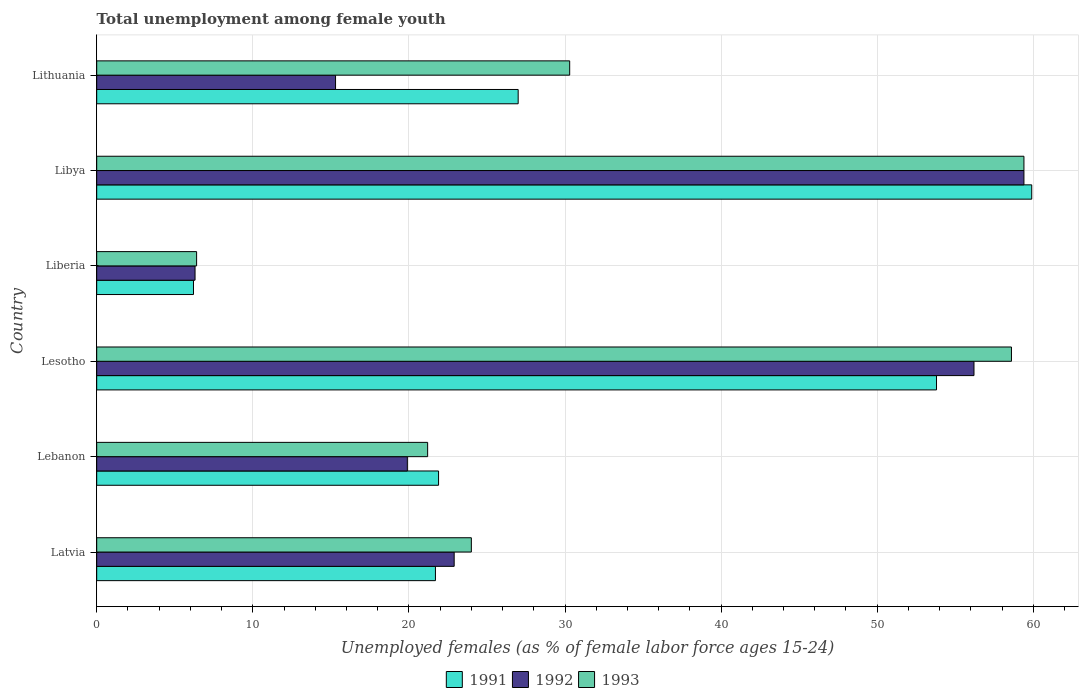How many different coloured bars are there?
Keep it short and to the point. 3. How many groups of bars are there?
Offer a very short reply. 6. How many bars are there on the 2nd tick from the bottom?
Offer a very short reply. 3. What is the label of the 1st group of bars from the top?
Your answer should be very brief. Lithuania. In how many cases, is the number of bars for a given country not equal to the number of legend labels?
Keep it short and to the point. 0. What is the percentage of unemployed females in in 1992 in Lebanon?
Offer a very short reply. 19.9. Across all countries, what is the maximum percentage of unemployed females in in 1991?
Provide a succinct answer. 59.9. Across all countries, what is the minimum percentage of unemployed females in in 1991?
Ensure brevity in your answer.  6.2. In which country was the percentage of unemployed females in in 1993 maximum?
Your answer should be compact. Libya. In which country was the percentage of unemployed females in in 1991 minimum?
Your answer should be compact. Liberia. What is the total percentage of unemployed females in in 1991 in the graph?
Your answer should be very brief. 190.5. What is the difference between the percentage of unemployed females in in 1992 in Lesotho and that in Liberia?
Your answer should be compact. 49.9. What is the difference between the percentage of unemployed females in in 1993 in Liberia and the percentage of unemployed females in in 1991 in Lithuania?
Provide a succinct answer. -20.6. What is the average percentage of unemployed females in in 1993 per country?
Make the answer very short. 33.32. In how many countries, is the percentage of unemployed females in in 1993 greater than 30 %?
Ensure brevity in your answer.  3. What is the ratio of the percentage of unemployed females in in 1992 in Lesotho to that in Liberia?
Make the answer very short. 8.92. Is the percentage of unemployed females in in 1991 in Lesotho less than that in Lithuania?
Your response must be concise. No. What is the difference between the highest and the second highest percentage of unemployed females in in 1993?
Provide a short and direct response. 0.8. What is the difference between the highest and the lowest percentage of unemployed females in in 1993?
Offer a very short reply. 53. What does the 1st bar from the top in Libya represents?
Your response must be concise. 1993. Is it the case that in every country, the sum of the percentage of unemployed females in in 1993 and percentage of unemployed females in in 1992 is greater than the percentage of unemployed females in in 1991?
Ensure brevity in your answer.  Yes. Are all the bars in the graph horizontal?
Offer a terse response. Yes. What is the difference between two consecutive major ticks on the X-axis?
Make the answer very short. 10. Are the values on the major ticks of X-axis written in scientific E-notation?
Your response must be concise. No. Does the graph contain any zero values?
Your answer should be very brief. No. What is the title of the graph?
Your response must be concise. Total unemployment among female youth. What is the label or title of the X-axis?
Give a very brief answer. Unemployed females (as % of female labor force ages 15-24). What is the label or title of the Y-axis?
Make the answer very short. Country. What is the Unemployed females (as % of female labor force ages 15-24) in 1991 in Latvia?
Make the answer very short. 21.7. What is the Unemployed females (as % of female labor force ages 15-24) of 1992 in Latvia?
Your answer should be compact. 22.9. What is the Unemployed females (as % of female labor force ages 15-24) in 1991 in Lebanon?
Offer a terse response. 21.9. What is the Unemployed females (as % of female labor force ages 15-24) of 1992 in Lebanon?
Your answer should be very brief. 19.9. What is the Unemployed females (as % of female labor force ages 15-24) in 1993 in Lebanon?
Your answer should be compact. 21.2. What is the Unemployed females (as % of female labor force ages 15-24) of 1991 in Lesotho?
Your response must be concise. 53.8. What is the Unemployed females (as % of female labor force ages 15-24) of 1992 in Lesotho?
Offer a very short reply. 56.2. What is the Unemployed females (as % of female labor force ages 15-24) in 1993 in Lesotho?
Offer a terse response. 58.6. What is the Unemployed females (as % of female labor force ages 15-24) of 1991 in Liberia?
Your answer should be compact. 6.2. What is the Unemployed females (as % of female labor force ages 15-24) in 1992 in Liberia?
Provide a succinct answer. 6.3. What is the Unemployed females (as % of female labor force ages 15-24) in 1993 in Liberia?
Offer a very short reply. 6.4. What is the Unemployed females (as % of female labor force ages 15-24) in 1991 in Libya?
Make the answer very short. 59.9. What is the Unemployed females (as % of female labor force ages 15-24) of 1992 in Libya?
Your answer should be very brief. 59.4. What is the Unemployed females (as % of female labor force ages 15-24) of 1993 in Libya?
Provide a short and direct response. 59.4. What is the Unemployed females (as % of female labor force ages 15-24) in 1991 in Lithuania?
Ensure brevity in your answer.  27. What is the Unemployed females (as % of female labor force ages 15-24) in 1992 in Lithuania?
Your answer should be compact. 15.3. What is the Unemployed females (as % of female labor force ages 15-24) in 1993 in Lithuania?
Make the answer very short. 30.3. Across all countries, what is the maximum Unemployed females (as % of female labor force ages 15-24) of 1991?
Your answer should be very brief. 59.9. Across all countries, what is the maximum Unemployed females (as % of female labor force ages 15-24) of 1992?
Your answer should be very brief. 59.4. Across all countries, what is the maximum Unemployed females (as % of female labor force ages 15-24) of 1993?
Offer a terse response. 59.4. Across all countries, what is the minimum Unemployed females (as % of female labor force ages 15-24) of 1991?
Give a very brief answer. 6.2. Across all countries, what is the minimum Unemployed females (as % of female labor force ages 15-24) of 1992?
Provide a short and direct response. 6.3. Across all countries, what is the minimum Unemployed females (as % of female labor force ages 15-24) in 1993?
Make the answer very short. 6.4. What is the total Unemployed females (as % of female labor force ages 15-24) of 1991 in the graph?
Give a very brief answer. 190.5. What is the total Unemployed females (as % of female labor force ages 15-24) in 1992 in the graph?
Offer a terse response. 180. What is the total Unemployed females (as % of female labor force ages 15-24) in 1993 in the graph?
Your answer should be compact. 199.9. What is the difference between the Unemployed females (as % of female labor force ages 15-24) in 1991 in Latvia and that in Lebanon?
Your answer should be compact. -0.2. What is the difference between the Unemployed females (as % of female labor force ages 15-24) in 1991 in Latvia and that in Lesotho?
Your response must be concise. -32.1. What is the difference between the Unemployed females (as % of female labor force ages 15-24) in 1992 in Latvia and that in Lesotho?
Your response must be concise. -33.3. What is the difference between the Unemployed females (as % of female labor force ages 15-24) of 1993 in Latvia and that in Lesotho?
Make the answer very short. -34.6. What is the difference between the Unemployed females (as % of female labor force ages 15-24) in 1993 in Latvia and that in Liberia?
Make the answer very short. 17.6. What is the difference between the Unemployed females (as % of female labor force ages 15-24) in 1991 in Latvia and that in Libya?
Give a very brief answer. -38.2. What is the difference between the Unemployed females (as % of female labor force ages 15-24) in 1992 in Latvia and that in Libya?
Keep it short and to the point. -36.5. What is the difference between the Unemployed females (as % of female labor force ages 15-24) of 1993 in Latvia and that in Libya?
Provide a short and direct response. -35.4. What is the difference between the Unemployed females (as % of female labor force ages 15-24) in 1991 in Latvia and that in Lithuania?
Offer a terse response. -5.3. What is the difference between the Unemployed females (as % of female labor force ages 15-24) in 1993 in Latvia and that in Lithuania?
Offer a very short reply. -6.3. What is the difference between the Unemployed females (as % of female labor force ages 15-24) in 1991 in Lebanon and that in Lesotho?
Make the answer very short. -31.9. What is the difference between the Unemployed females (as % of female labor force ages 15-24) of 1992 in Lebanon and that in Lesotho?
Offer a terse response. -36.3. What is the difference between the Unemployed females (as % of female labor force ages 15-24) in 1993 in Lebanon and that in Lesotho?
Your answer should be compact. -37.4. What is the difference between the Unemployed females (as % of female labor force ages 15-24) of 1991 in Lebanon and that in Liberia?
Ensure brevity in your answer.  15.7. What is the difference between the Unemployed females (as % of female labor force ages 15-24) in 1991 in Lebanon and that in Libya?
Provide a short and direct response. -38. What is the difference between the Unemployed females (as % of female labor force ages 15-24) in 1992 in Lebanon and that in Libya?
Your answer should be compact. -39.5. What is the difference between the Unemployed females (as % of female labor force ages 15-24) of 1993 in Lebanon and that in Libya?
Give a very brief answer. -38.2. What is the difference between the Unemployed females (as % of female labor force ages 15-24) of 1992 in Lebanon and that in Lithuania?
Make the answer very short. 4.6. What is the difference between the Unemployed females (as % of female labor force ages 15-24) of 1993 in Lebanon and that in Lithuania?
Your answer should be very brief. -9.1. What is the difference between the Unemployed females (as % of female labor force ages 15-24) in 1991 in Lesotho and that in Liberia?
Your answer should be very brief. 47.6. What is the difference between the Unemployed females (as % of female labor force ages 15-24) of 1992 in Lesotho and that in Liberia?
Provide a short and direct response. 49.9. What is the difference between the Unemployed females (as % of female labor force ages 15-24) in 1993 in Lesotho and that in Liberia?
Your answer should be compact. 52.2. What is the difference between the Unemployed females (as % of female labor force ages 15-24) in 1991 in Lesotho and that in Libya?
Offer a very short reply. -6.1. What is the difference between the Unemployed females (as % of female labor force ages 15-24) of 1993 in Lesotho and that in Libya?
Your answer should be very brief. -0.8. What is the difference between the Unemployed females (as % of female labor force ages 15-24) of 1991 in Lesotho and that in Lithuania?
Your response must be concise. 26.8. What is the difference between the Unemployed females (as % of female labor force ages 15-24) of 1992 in Lesotho and that in Lithuania?
Give a very brief answer. 40.9. What is the difference between the Unemployed females (as % of female labor force ages 15-24) in 1993 in Lesotho and that in Lithuania?
Provide a succinct answer. 28.3. What is the difference between the Unemployed females (as % of female labor force ages 15-24) in 1991 in Liberia and that in Libya?
Offer a very short reply. -53.7. What is the difference between the Unemployed females (as % of female labor force ages 15-24) of 1992 in Liberia and that in Libya?
Give a very brief answer. -53.1. What is the difference between the Unemployed females (as % of female labor force ages 15-24) in 1993 in Liberia and that in Libya?
Your answer should be compact. -53. What is the difference between the Unemployed females (as % of female labor force ages 15-24) of 1991 in Liberia and that in Lithuania?
Offer a very short reply. -20.8. What is the difference between the Unemployed females (as % of female labor force ages 15-24) in 1993 in Liberia and that in Lithuania?
Keep it short and to the point. -23.9. What is the difference between the Unemployed females (as % of female labor force ages 15-24) in 1991 in Libya and that in Lithuania?
Your answer should be very brief. 32.9. What is the difference between the Unemployed females (as % of female labor force ages 15-24) of 1992 in Libya and that in Lithuania?
Offer a terse response. 44.1. What is the difference between the Unemployed females (as % of female labor force ages 15-24) in 1993 in Libya and that in Lithuania?
Make the answer very short. 29.1. What is the difference between the Unemployed females (as % of female labor force ages 15-24) of 1992 in Latvia and the Unemployed females (as % of female labor force ages 15-24) of 1993 in Lebanon?
Provide a succinct answer. 1.7. What is the difference between the Unemployed females (as % of female labor force ages 15-24) in 1991 in Latvia and the Unemployed females (as % of female labor force ages 15-24) in 1992 in Lesotho?
Provide a short and direct response. -34.5. What is the difference between the Unemployed females (as % of female labor force ages 15-24) of 1991 in Latvia and the Unemployed females (as % of female labor force ages 15-24) of 1993 in Lesotho?
Provide a succinct answer. -36.9. What is the difference between the Unemployed females (as % of female labor force ages 15-24) in 1992 in Latvia and the Unemployed females (as % of female labor force ages 15-24) in 1993 in Lesotho?
Provide a succinct answer. -35.7. What is the difference between the Unemployed females (as % of female labor force ages 15-24) in 1991 in Latvia and the Unemployed females (as % of female labor force ages 15-24) in 1993 in Liberia?
Give a very brief answer. 15.3. What is the difference between the Unemployed females (as % of female labor force ages 15-24) in 1992 in Latvia and the Unemployed females (as % of female labor force ages 15-24) in 1993 in Liberia?
Keep it short and to the point. 16.5. What is the difference between the Unemployed females (as % of female labor force ages 15-24) of 1991 in Latvia and the Unemployed females (as % of female labor force ages 15-24) of 1992 in Libya?
Provide a succinct answer. -37.7. What is the difference between the Unemployed females (as % of female labor force ages 15-24) of 1991 in Latvia and the Unemployed females (as % of female labor force ages 15-24) of 1993 in Libya?
Make the answer very short. -37.7. What is the difference between the Unemployed females (as % of female labor force ages 15-24) in 1992 in Latvia and the Unemployed females (as % of female labor force ages 15-24) in 1993 in Libya?
Provide a short and direct response. -36.5. What is the difference between the Unemployed females (as % of female labor force ages 15-24) in 1991 in Latvia and the Unemployed females (as % of female labor force ages 15-24) in 1992 in Lithuania?
Your answer should be very brief. 6.4. What is the difference between the Unemployed females (as % of female labor force ages 15-24) of 1991 in Latvia and the Unemployed females (as % of female labor force ages 15-24) of 1993 in Lithuania?
Give a very brief answer. -8.6. What is the difference between the Unemployed females (as % of female labor force ages 15-24) of 1992 in Latvia and the Unemployed females (as % of female labor force ages 15-24) of 1993 in Lithuania?
Offer a terse response. -7.4. What is the difference between the Unemployed females (as % of female labor force ages 15-24) of 1991 in Lebanon and the Unemployed females (as % of female labor force ages 15-24) of 1992 in Lesotho?
Provide a succinct answer. -34.3. What is the difference between the Unemployed females (as % of female labor force ages 15-24) in 1991 in Lebanon and the Unemployed females (as % of female labor force ages 15-24) in 1993 in Lesotho?
Your answer should be very brief. -36.7. What is the difference between the Unemployed females (as % of female labor force ages 15-24) of 1992 in Lebanon and the Unemployed females (as % of female labor force ages 15-24) of 1993 in Lesotho?
Offer a very short reply. -38.7. What is the difference between the Unemployed females (as % of female labor force ages 15-24) in 1991 in Lebanon and the Unemployed females (as % of female labor force ages 15-24) in 1992 in Liberia?
Keep it short and to the point. 15.6. What is the difference between the Unemployed females (as % of female labor force ages 15-24) of 1991 in Lebanon and the Unemployed females (as % of female labor force ages 15-24) of 1992 in Libya?
Offer a very short reply. -37.5. What is the difference between the Unemployed females (as % of female labor force ages 15-24) of 1991 in Lebanon and the Unemployed females (as % of female labor force ages 15-24) of 1993 in Libya?
Make the answer very short. -37.5. What is the difference between the Unemployed females (as % of female labor force ages 15-24) of 1992 in Lebanon and the Unemployed females (as % of female labor force ages 15-24) of 1993 in Libya?
Keep it short and to the point. -39.5. What is the difference between the Unemployed females (as % of female labor force ages 15-24) in 1991 in Lebanon and the Unemployed females (as % of female labor force ages 15-24) in 1992 in Lithuania?
Give a very brief answer. 6.6. What is the difference between the Unemployed females (as % of female labor force ages 15-24) in 1992 in Lebanon and the Unemployed females (as % of female labor force ages 15-24) in 1993 in Lithuania?
Make the answer very short. -10.4. What is the difference between the Unemployed females (as % of female labor force ages 15-24) in 1991 in Lesotho and the Unemployed females (as % of female labor force ages 15-24) in 1992 in Liberia?
Keep it short and to the point. 47.5. What is the difference between the Unemployed females (as % of female labor force ages 15-24) in 1991 in Lesotho and the Unemployed females (as % of female labor force ages 15-24) in 1993 in Liberia?
Your answer should be compact. 47.4. What is the difference between the Unemployed females (as % of female labor force ages 15-24) of 1992 in Lesotho and the Unemployed females (as % of female labor force ages 15-24) of 1993 in Liberia?
Your answer should be very brief. 49.8. What is the difference between the Unemployed females (as % of female labor force ages 15-24) in 1991 in Lesotho and the Unemployed females (as % of female labor force ages 15-24) in 1993 in Libya?
Give a very brief answer. -5.6. What is the difference between the Unemployed females (as % of female labor force ages 15-24) in 1991 in Lesotho and the Unemployed females (as % of female labor force ages 15-24) in 1992 in Lithuania?
Your answer should be compact. 38.5. What is the difference between the Unemployed females (as % of female labor force ages 15-24) in 1992 in Lesotho and the Unemployed females (as % of female labor force ages 15-24) in 1993 in Lithuania?
Your response must be concise. 25.9. What is the difference between the Unemployed females (as % of female labor force ages 15-24) of 1991 in Liberia and the Unemployed females (as % of female labor force ages 15-24) of 1992 in Libya?
Keep it short and to the point. -53.2. What is the difference between the Unemployed females (as % of female labor force ages 15-24) in 1991 in Liberia and the Unemployed females (as % of female labor force ages 15-24) in 1993 in Libya?
Offer a terse response. -53.2. What is the difference between the Unemployed females (as % of female labor force ages 15-24) in 1992 in Liberia and the Unemployed females (as % of female labor force ages 15-24) in 1993 in Libya?
Provide a short and direct response. -53.1. What is the difference between the Unemployed females (as % of female labor force ages 15-24) of 1991 in Liberia and the Unemployed females (as % of female labor force ages 15-24) of 1992 in Lithuania?
Provide a succinct answer. -9.1. What is the difference between the Unemployed females (as % of female labor force ages 15-24) in 1991 in Liberia and the Unemployed females (as % of female labor force ages 15-24) in 1993 in Lithuania?
Give a very brief answer. -24.1. What is the difference between the Unemployed females (as % of female labor force ages 15-24) of 1991 in Libya and the Unemployed females (as % of female labor force ages 15-24) of 1992 in Lithuania?
Your response must be concise. 44.6. What is the difference between the Unemployed females (as % of female labor force ages 15-24) in 1991 in Libya and the Unemployed females (as % of female labor force ages 15-24) in 1993 in Lithuania?
Provide a succinct answer. 29.6. What is the difference between the Unemployed females (as % of female labor force ages 15-24) in 1992 in Libya and the Unemployed females (as % of female labor force ages 15-24) in 1993 in Lithuania?
Offer a very short reply. 29.1. What is the average Unemployed females (as % of female labor force ages 15-24) in 1991 per country?
Make the answer very short. 31.75. What is the average Unemployed females (as % of female labor force ages 15-24) of 1992 per country?
Ensure brevity in your answer.  30. What is the average Unemployed females (as % of female labor force ages 15-24) in 1993 per country?
Offer a terse response. 33.32. What is the difference between the Unemployed females (as % of female labor force ages 15-24) of 1991 and Unemployed females (as % of female labor force ages 15-24) of 1993 in Latvia?
Offer a very short reply. -2.3. What is the difference between the Unemployed females (as % of female labor force ages 15-24) of 1992 and Unemployed females (as % of female labor force ages 15-24) of 1993 in Latvia?
Provide a succinct answer. -1.1. What is the difference between the Unemployed females (as % of female labor force ages 15-24) of 1991 and Unemployed females (as % of female labor force ages 15-24) of 1993 in Lebanon?
Your answer should be compact. 0.7. What is the difference between the Unemployed females (as % of female labor force ages 15-24) of 1992 and Unemployed females (as % of female labor force ages 15-24) of 1993 in Lebanon?
Your answer should be compact. -1.3. What is the difference between the Unemployed females (as % of female labor force ages 15-24) in 1991 and Unemployed females (as % of female labor force ages 15-24) in 1992 in Lesotho?
Provide a succinct answer. -2.4. What is the difference between the Unemployed females (as % of female labor force ages 15-24) of 1991 and Unemployed females (as % of female labor force ages 15-24) of 1993 in Liberia?
Offer a very short reply. -0.2. What is the difference between the Unemployed females (as % of female labor force ages 15-24) in 1991 and Unemployed females (as % of female labor force ages 15-24) in 1993 in Libya?
Make the answer very short. 0.5. What is the difference between the Unemployed females (as % of female labor force ages 15-24) in 1992 and Unemployed females (as % of female labor force ages 15-24) in 1993 in Libya?
Keep it short and to the point. 0. What is the difference between the Unemployed females (as % of female labor force ages 15-24) in 1991 and Unemployed females (as % of female labor force ages 15-24) in 1992 in Lithuania?
Provide a succinct answer. 11.7. What is the difference between the Unemployed females (as % of female labor force ages 15-24) in 1992 and Unemployed females (as % of female labor force ages 15-24) in 1993 in Lithuania?
Give a very brief answer. -15. What is the ratio of the Unemployed females (as % of female labor force ages 15-24) of 1991 in Latvia to that in Lebanon?
Keep it short and to the point. 0.99. What is the ratio of the Unemployed females (as % of female labor force ages 15-24) in 1992 in Latvia to that in Lebanon?
Ensure brevity in your answer.  1.15. What is the ratio of the Unemployed females (as % of female labor force ages 15-24) of 1993 in Latvia to that in Lebanon?
Give a very brief answer. 1.13. What is the ratio of the Unemployed females (as % of female labor force ages 15-24) of 1991 in Latvia to that in Lesotho?
Provide a succinct answer. 0.4. What is the ratio of the Unemployed females (as % of female labor force ages 15-24) of 1992 in Latvia to that in Lesotho?
Your answer should be very brief. 0.41. What is the ratio of the Unemployed females (as % of female labor force ages 15-24) in 1993 in Latvia to that in Lesotho?
Keep it short and to the point. 0.41. What is the ratio of the Unemployed females (as % of female labor force ages 15-24) in 1991 in Latvia to that in Liberia?
Provide a short and direct response. 3.5. What is the ratio of the Unemployed females (as % of female labor force ages 15-24) in 1992 in Latvia to that in Liberia?
Provide a succinct answer. 3.63. What is the ratio of the Unemployed females (as % of female labor force ages 15-24) in 1993 in Latvia to that in Liberia?
Provide a short and direct response. 3.75. What is the ratio of the Unemployed females (as % of female labor force ages 15-24) of 1991 in Latvia to that in Libya?
Ensure brevity in your answer.  0.36. What is the ratio of the Unemployed females (as % of female labor force ages 15-24) of 1992 in Latvia to that in Libya?
Your answer should be very brief. 0.39. What is the ratio of the Unemployed females (as % of female labor force ages 15-24) in 1993 in Latvia to that in Libya?
Your answer should be very brief. 0.4. What is the ratio of the Unemployed females (as % of female labor force ages 15-24) of 1991 in Latvia to that in Lithuania?
Your answer should be compact. 0.8. What is the ratio of the Unemployed females (as % of female labor force ages 15-24) in 1992 in Latvia to that in Lithuania?
Ensure brevity in your answer.  1.5. What is the ratio of the Unemployed females (as % of female labor force ages 15-24) in 1993 in Latvia to that in Lithuania?
Offer a terse response. 0.79. What is the ratio of the Unemployed females (as % of female labor force ages 15-24) of 1991 in Lebanon to that in Lesotho?
Your response must be concise. 0.41. What is the ratio of the Unemployed females (as % of female labor force ages 15-24) in 1992 in Lebanon to that in Lesotho?
Your answer should be very brief. 0.35. What is the ratio of the Unemployed females (as % of female labor force ages 15-24) in 1993 in Lebanon to that in Lesotho?
Make the answer very short. 0.36. What is the ratio of the Unemployed females (as % of female labor force ages 15-24) of 1991 in Lebanon to that in Liberia?
Ensure brevity in your answer.  3.53. What is the ratio of the Unemployed females (as % of female labor force ages 15-24) in 1992 in Lebanon to that in Liberia?
Your response must be concise. 3.16. What is the ratio of the Unemployed females (as % of female labor force ages 15-24) of 1993 in Lebanon to that in Liberia?
Provide a short and direct response. 3.31. What is the ratio of the Unemployed females (as % of female labor force ages 15-24) of 1991 in Lebanon to that in Libya?
Your answer should be very brief. 0.37. What is the ratio of the Unemployed females (as % of female labor force ages 15-24) of 1992 in Lebanon to that in Libya?
Offer a terse response. 0.34. What is the ratio of the Unemployed females (as % of female labor force ages 15-24) in 1993 in Lebanon to that in Libya?
Keep it short and to the point. 0.36. What is the ratio of the Unemployed females (as % of female labor force ages 15-24) in 1991 in Lebanon to that in Lithuania?
Offer a very short reply. 0.81. What is the ratio of the Unemployed females (as % of female labor force ages 15-24) of 1992 in Lebanon to that in Lithuania?
Your answer should be very brief. 1.3. What is the ratio of the Unemployed females (as % of female labor force ages 15-24) of 1993 in Lebanon to that in Lithuania?
Your answer should be very brief. 0.7. What is the ratio of the Unemployed females (as % of female labor force ages 15-24) in 1991 in Lesotho to that in Liberia?
Ensure brevity in your answer.  8.68. What is the ratio of the Unemployed females (as % of female labor force ages 15-24) of 1992 in Lesotho to that in Liberia?
Ensure brevity in your answer.  8.92. What is the ratio of the Unemployed females (as % of female labor force ages 15-24) of 1993 in Lesotho to that in Liberia?
Provide a short and direct response. 9.16. What is the ratio of the Unemployed females (as % of female labor force ages 15-24) of 1991 in Lesotho to that in Libya?
Make the answer very short. 0.9. What is the ratio of the Unemployed females (as % of female labor force ages 15-24) in 1992 in Lesotho to that in Libya?
Your answer should be compact. 0.95. What is the ratio of the Unemployed females (as % of female labor force ages 15-24) of 1993 in Lesotho to that in Libya?
Give a very brief answer. 0.99. What is the ratio of the Unemployed females (as % of female labor force ages 15-24) of 1991 in Lesotho to that in Lithuania?
Keep it short and to the point. 1.99. What is the ratio of the Unemployed females (as % of female labor force ages 15-24) in 1992 in Lesotho to that in Lithuania?
Offer a terse response. 3.67. What is the ratio of the Unemployed females (as % of female labor force ages 15-24) in 1993 in Lesotho to that in Lithuania?
Your answer should be compact. 1.93. What is the ratio of the Unemployed females (as % of female labor force ages 15-24) of 1991 in Liberia to that in Libya?
Provide a succinct answer. 0.1. What is the ratio of the Unemployed females (as % of female labor force ages 15-24) in 1992 in Liberia to that in Libya?
Offer a very short reply. 0.11. What is the ratio of the Unemployed females (as % of female labor force ages 15-24) of 1993 in Liberia to that in Libya?
Keep it short and to the point. 0.11. What is the ratio of the Unemployed females (as % of female labor force ages 15-24) in 1991 in Liberia to that in Lithuania?
Make the answer very short. 0.23. What is the ratio of the Unemployed females (as % of female labor force ages 15-24) of 1992 in Liberia to that in Lithuania?
Offer a very short reply. 0.41. What is the ratio of the Unemployed females (as % of female labor force ages 15-24) in 1993 in Liberia to that in Lithuania?
Your response must be concise. 0.21. What is the ratio of the Unemployed females (as % of female labor force ages 15-24) of 1991 in Libya to that in Lithuania?
Ensure brevity in your answer.  2.22. What is the ratio of the Unemployed females (as % of female labor force ages 15-24) in 1992 in Libya to that in Lithuania?
Your answer should be very brief. 3.88. What is the ratio of the Unemployed females (as % of female labor force ages 15-24) in 1993 in Libya to that in Lithuania?
Offer a very short reply. 1.96. What is the difference between the highest and the second highest Unemployed females (as % of female labor force ages 15-24) of 1991?
Your response must be concise. 6.1. What is the difference between the highest and the second highest Unemployed females (as % of female labor force ages 15-24) of 1993?
Give a very brief answer. 0.8. What is the difference between the highest and the lowest Unemployed females (as % of female labor force ages 15-24) in 1991?
Provide a succinct answer. 53.7. What is the difference between the highest and the lowest Unemployed females (as % of female labor force ages 15-24) of 1992?
Your answer should be compact. 53.1. What is the difference between the highest and the lowest Unemployed females (as % of female labor force ages 15-24) in 1993?
Keep it short and to the point. 53. 